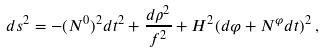Convert formula to latex. <formula><loc_0><loc_0><loc_500><loc_500>d s ^ { 2 } = - ( N ^ { 0 } ) ^ { 2 } d t ^ { 2 } + \frac { d \rho ^ { 2 } } { f ^ { 2 } } + H ^ { 2 } ( d \varphi + N ^ { \varphi } d t ) ^ { 2 } \, ,</formula> 